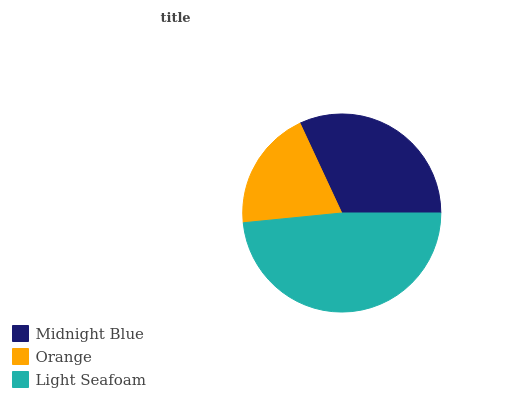Is Orange the minimum?
Answer yes or no. Yes. Is Light Seafoam the maximum?
Answer yes or no. Yes. Is Light Seafoam the minimum?
Answer yes or no. No. Is Orange the maximum?
Answer yes or no. No. Is Light Seafoam greater than Orange?
Answer yes or no. Yes. Is Orange less than Light Seafoam?
Answer yes or no. Yes. Is Orange greater than Light Seafoam?
Answer yes or no. No. Is Light Seafoam less than Orange?
Answer yes or no. No. Is Midnight Blue the high median?
Answer yes or no. Yes. Is Midnight Blue the low median?
Answer yes or no. Yes. Is Orange the high median?
Answer yes or no. No. Is Light Seafoam the low median?
Answer yes or no. No. 